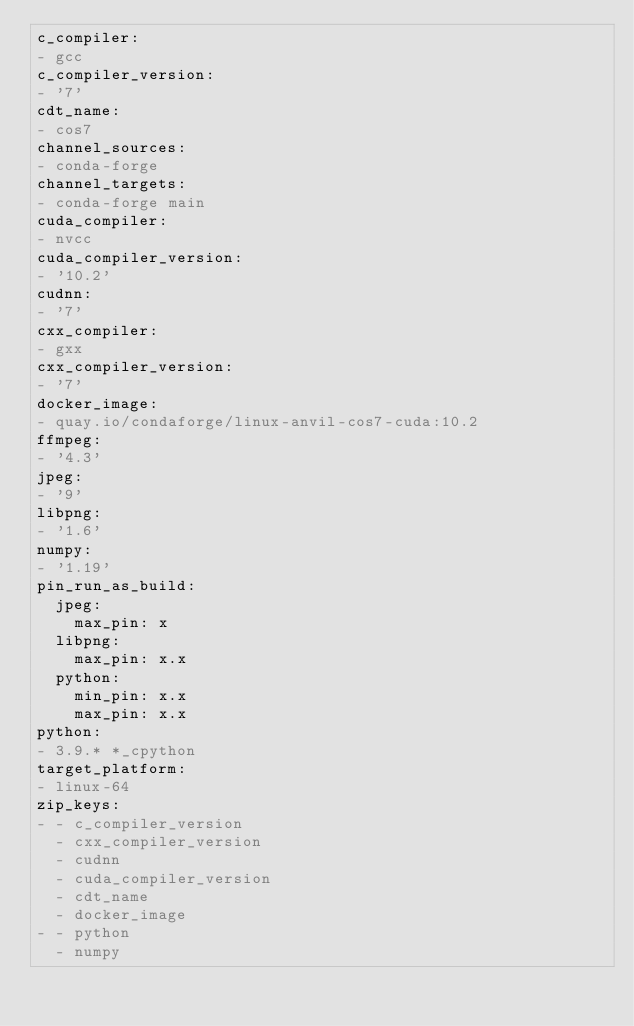<code> <loc_0><loc_0><loc_500><loc_500><_YAML_>c_compiler:
- gcc
c_compiler_version:
- '7'
cdt_name:
- cos7
channel_sources:
- conda-forge
channel_targets:
- conda-forge main
cuda_compiler:
- nvcc
cuda_compiler_version:
- '10.2'
cudnn:
- '7'
cxx_compiler:
- gxx
cxx_compiler_version:
- '7'
docker_image:
- quay.io/condaforge/linux-anvil-cos7-cuda:10.2
ffmpeg:
- '4.3'
jpeg:
- '9'
libpng:
- '1.6'
numpy:
- '1.19'
pin_run_as_build:
  jpeg:
    max_pin: x
  libpng:
    max_pin: x.x
  python:
    min_pin: x.x
    max_pin: x.x
python:
- 3.9.* *_cpython
target_platform:
- linux-64
zip_keys:
- - c_compiler_version
  - cxx_compiler_version
  - cudnn
  - cuda_compiler_version
  - cdt_name
  - docker_image
- - python
  - numpy
</code> 